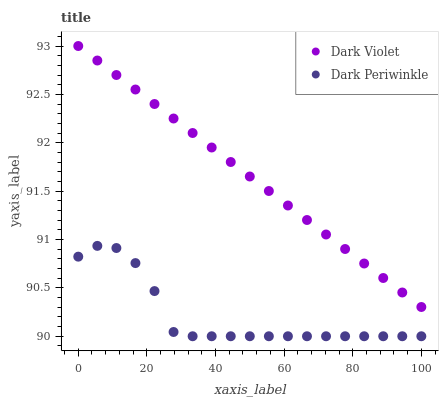Does Dark Periwinkle have the minimum area under the curve?
Answer yes or no. Yes. Does Dark Violet have the maximum area under the curve?
Answer yes or no. Yes. Does Dark Violet have the minimum area under the curve?
Answer yes or no. No. Is Dark Violet the smoothest?
Answer yes or no. Yes. Is Dark Periwinkle the roughest?
Answer yes or no. Yes. Is Dark Violet the roughest?
Answer yes or no. No. Does Dark Periwinkle have the lowest value?
Answer yes or no. Yes. Does Dark Violet have the lowest value?
Answer yes or no. No. Does Dark Violet have the highest value?
Answer yes or no. Yes. Is Dark Periwinkle less than Dark Violet?
Answer yes or no. Yes. Is Dark Violet greater than Dark Periwinkle?
Answer yes or no. Yes. Does Dark Periwinkle intersect Dark Violet?
Answer yes or no. No. 